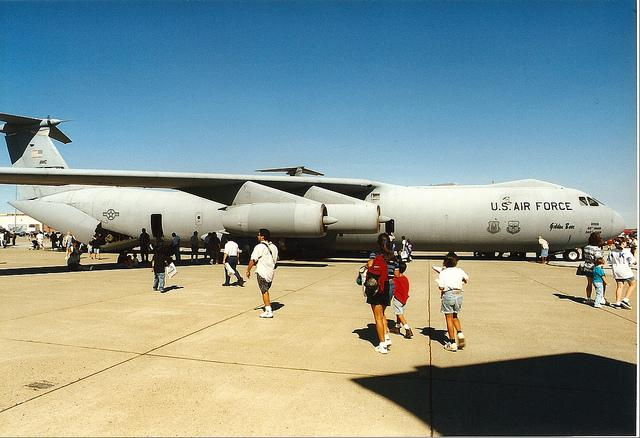What type of military individual fly's this plane?

Choices:
A) marine
B) airmen
C) seaman
D) soldier airmen 